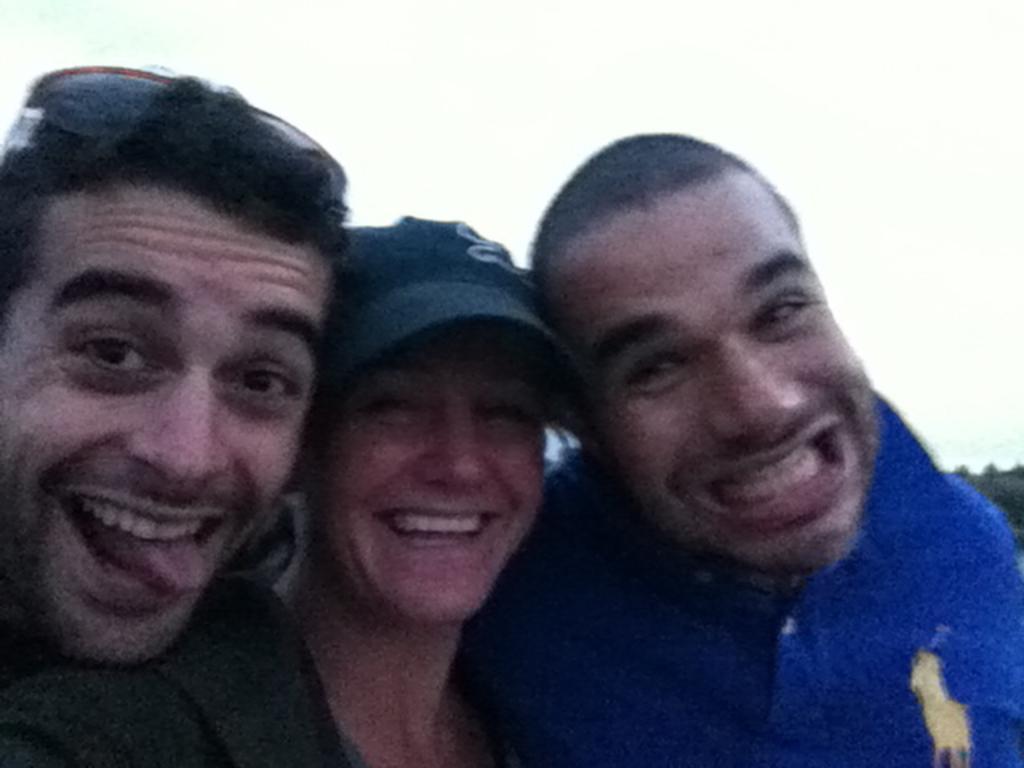In one or two sentences, can you explain what this image depicts? In this picture there are people in the center of the image. 